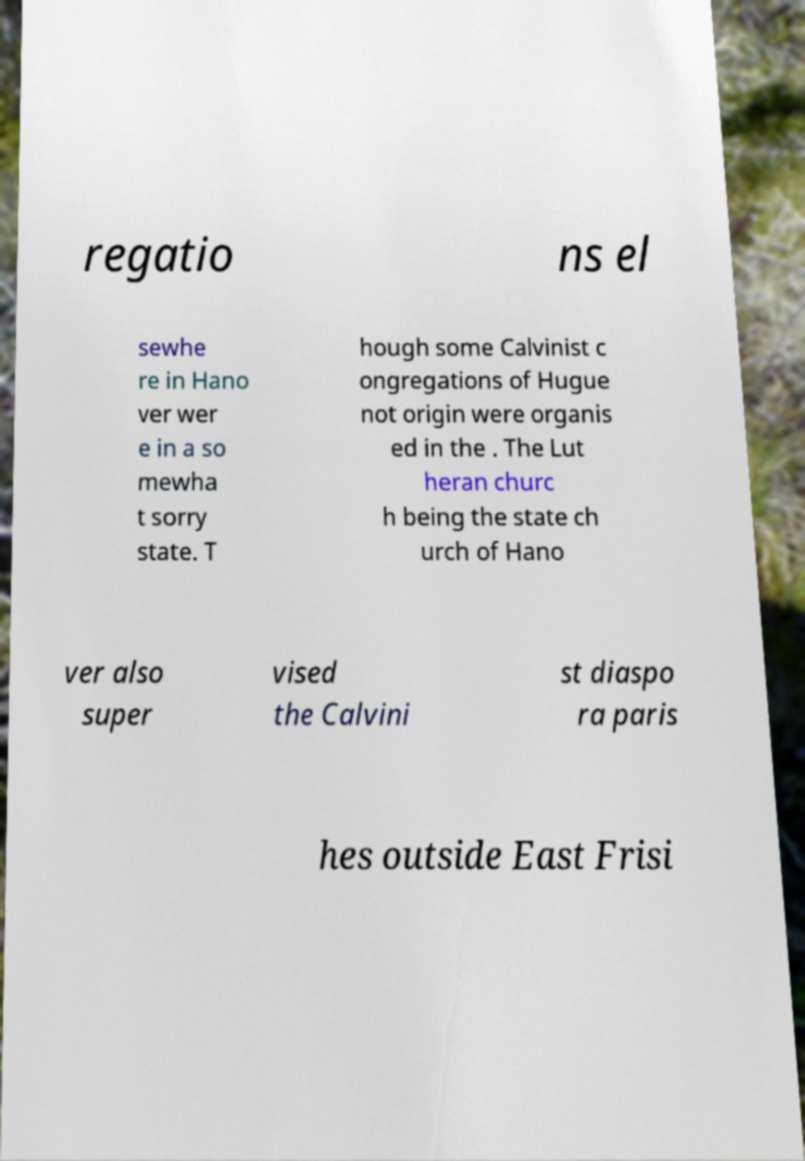Please identify and transcribe the text found in this image. regatio ns el sewhe re in Hano ver wer e in a so mewha t sorry state. T hough some Calvinist c ongregations of Hugue not origin were organis ed in the . The Lut heran churc h being the state ch urch of Hano ver also super vised the Calvini st diaspo ra paris hes outside East Frisi 